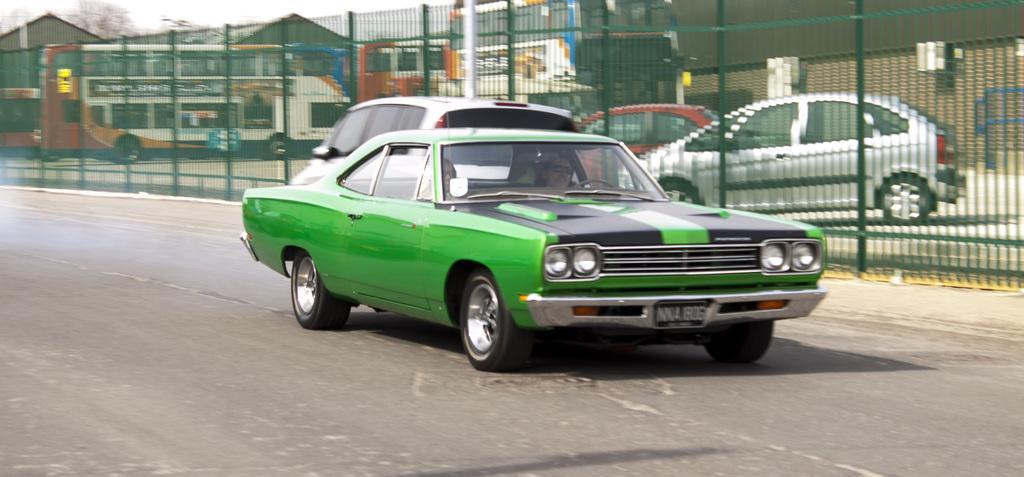Can you describe this image briefly? In this picture we can see cars on the road and fence, through this fence we can see vehicles. In the background of the image we can see the sky. 